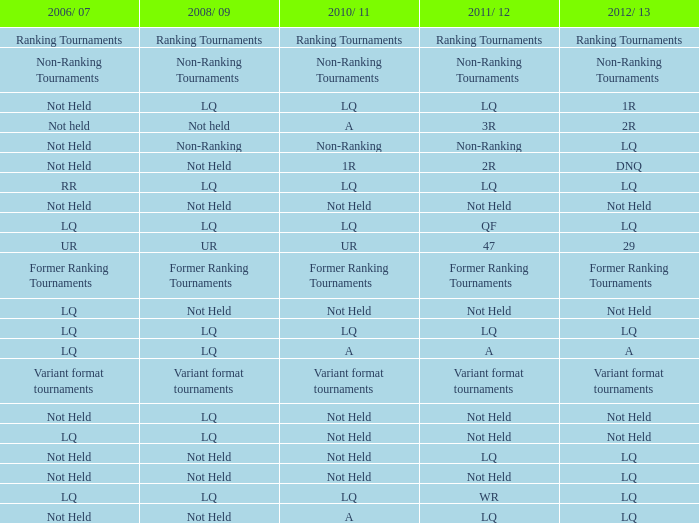What is 2006/07, when 2008/09 is LQ, and when 2010/11 is Not Held? LQ, Not Held. 